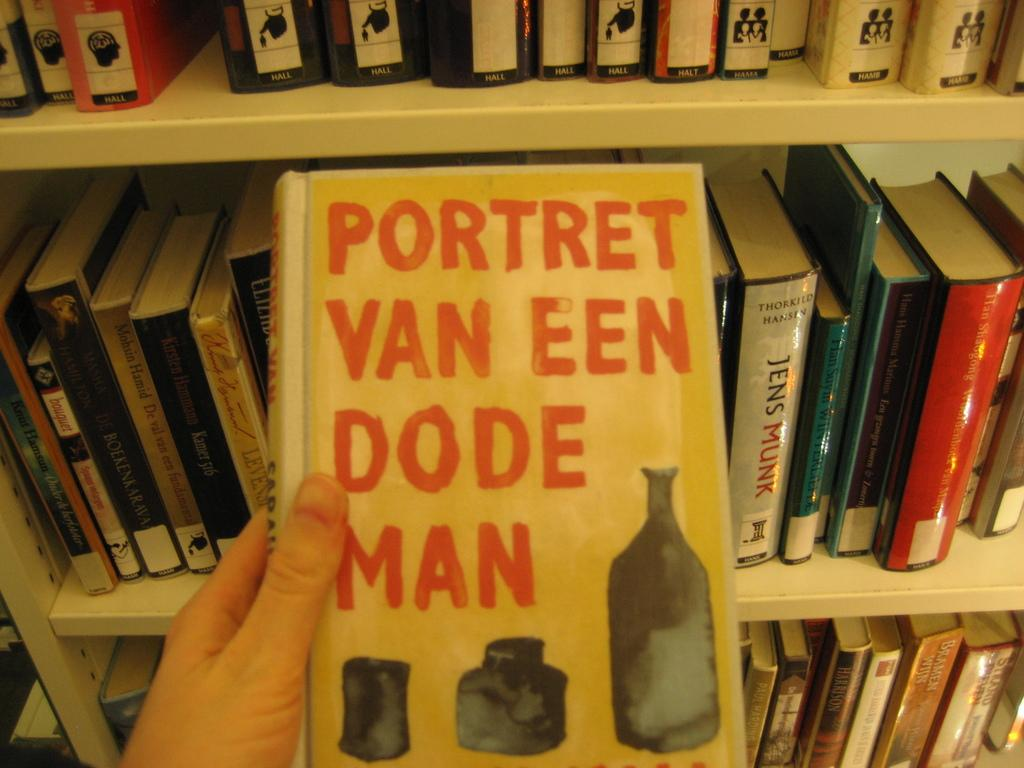<image>
Give a short and clear explanation of the subsequent image. A yellow book of Portret Van Een Dode Man. 